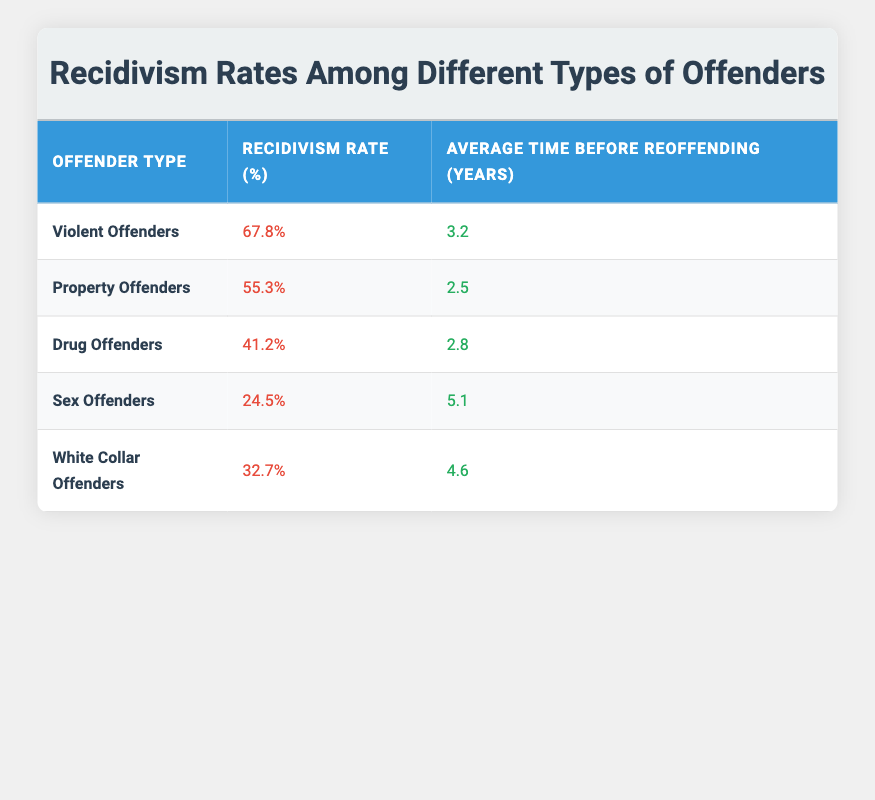What is the recidivism rate for violent offenders? The table shows that the recidivism rate for Violent Offenders is specifically listed in the row for this offender type. Looking at that row, the corresponding rate is 67.8%.
Answer: 67.8% Which type of offenders has the highest average time before reoffending? The average time before reoffending is indicated in the table for each offender type. Comparing all the values, Sex Offenders have the highest average time before reoffending at 5.1 years.
Answer: Sex Offenders What is the difference in recidivism rates between property offenders and drug offenders? The recidivism rate for Property Offenders is 55.3% and for Drug Offenders it is 41.2%. The difference can be calculated by subtracting the Drug Offender rate from the Property Offender rate: 55.3% - 41.2% = 14.1%.
Answer: 14.1% Is the recidivism rate for white-collar offenders higher than for sex offenders? The table lists 32.7% as the recidivism rate for White Collar Offenders and 24.5% for Sex Offenders. Since 32.7% is greater than 24.5%, this statement is true.
Answer: Yes What is the average recidivism rate among all offender types listed in the table? First, sum the recidivism rates for all offender types: 67.8 + 55.3 + 41.2 + 24.5 + 32.7 = 221.5. Then divide by the number of offender types, which is 5: 221.5 / 5 = 44.3%.
Answer: 44.3% How many offender types have a recidivism rate above 40%? By looking at the table, we see that Violent Offenders (67.8%), Property Offenders (55.3%), and Drug Offenders (41.2%) have rates above 40%. Counting these offenders gives us a total of three offender types.
Answer: 3 Which offenders take the longest average time before reoffending? By examining the table, we identify that the time before reoffending is highest for Sex Offenders at 5.1 years, as shown in their respective row.
Answer: Sex Offenders Is it true that the recidivism rate for drug offenders is lower than that of property offenders? The recidivism rate for Drug Offenders is 41.2%, and for Property Offenders, it is 55.3%. Since 41.2% is less than 55.3%, the statement is true.
Answer: Yes 